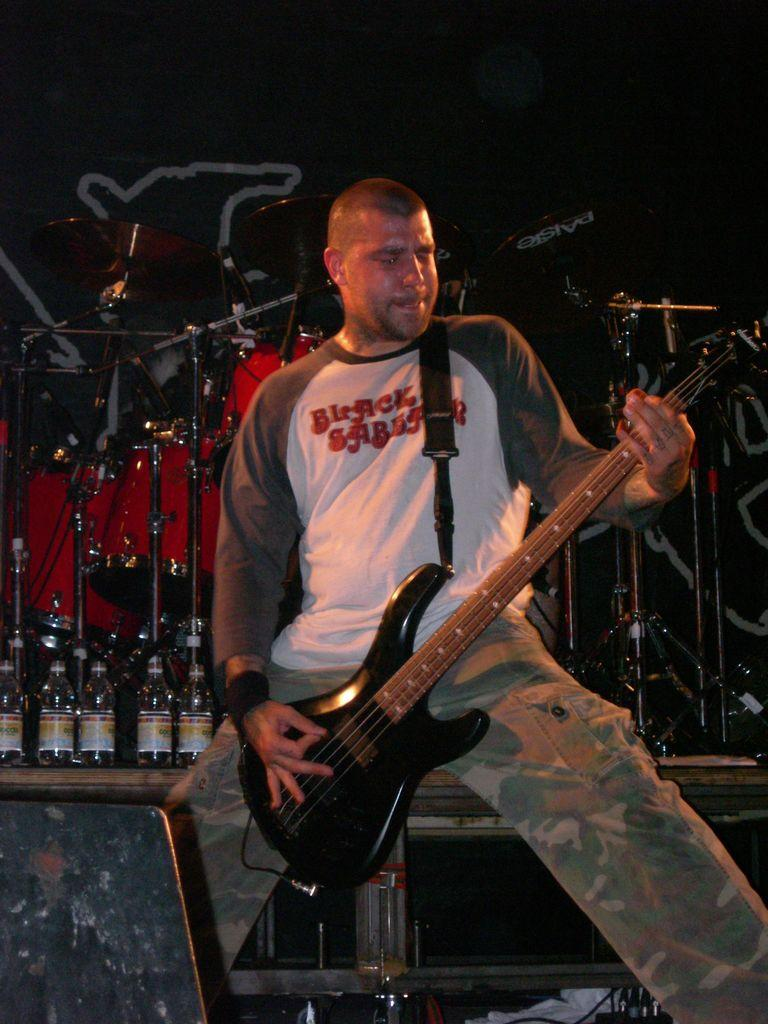Who is the main subject in the image? There is a man in the image. Where is the man located in the image? The man is standing on a stage. What is the man doing in the image? The man is playing a guitar. What else can be seen in the image besides the man? There are multiple musical instruments visible in the image. What type of jeans is the man wearing in the image? There is no information about the man's jeans in the image. 